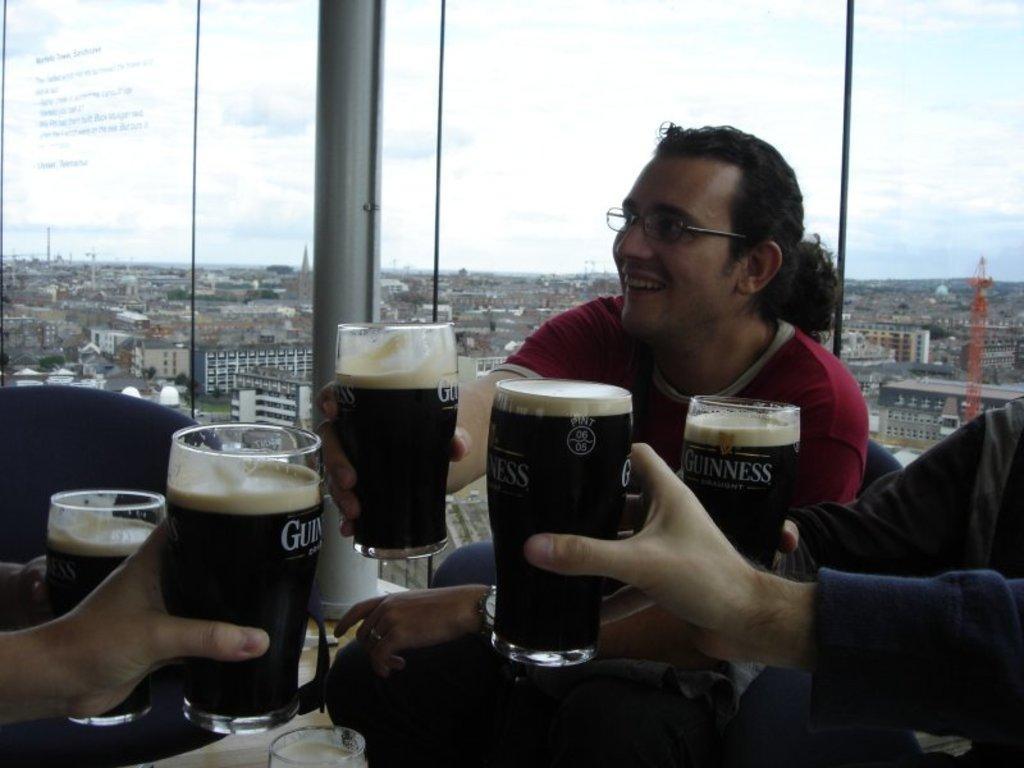In one or two sentences, can you explain what this image depicts? In this picture there is a person sitting in the chair and holding a glass. There are few other people sitting in the chair and holding glasses in their hands. Sky is blue and cloudy. Many buildings are visible in the background. 